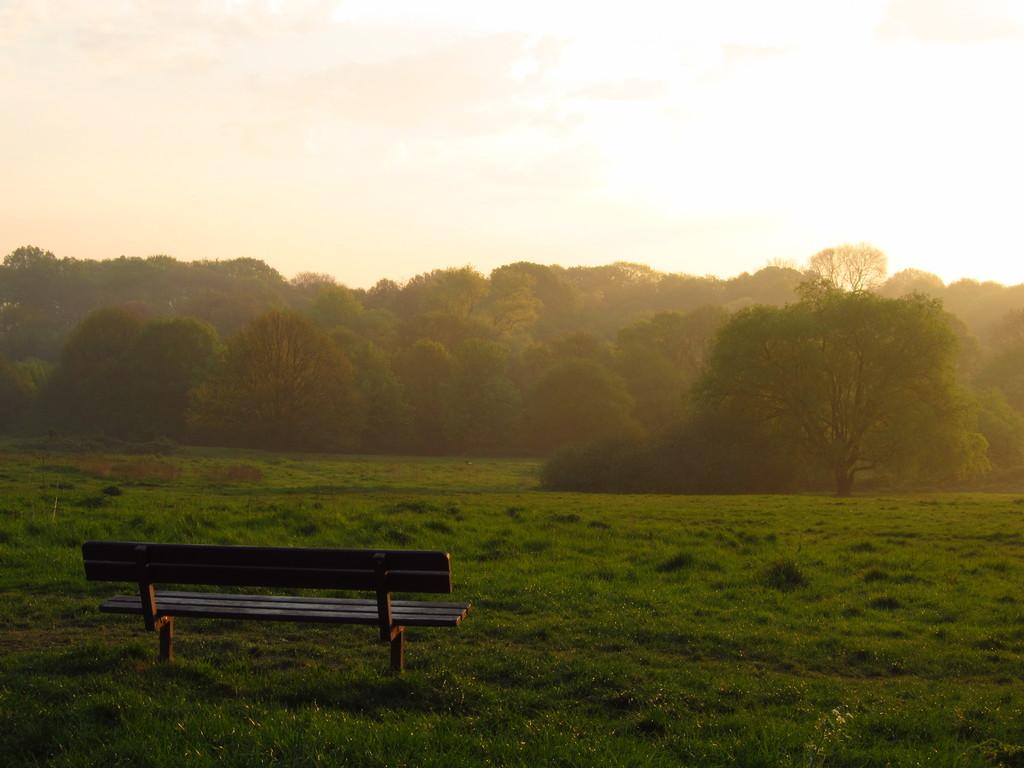What type of seating is located on the left side of the image? There is a bench on the left side of the image. What type of vegetation is present at the bottom of the image? Grass is present at the bottom of the image. What can be seen in the background of the image? There are trees and the sky visible in the background of the image. Where is the sink located in the image? There is no sink present in the image. What color is the sock on the bench in the image? There is no sock present in the image. 